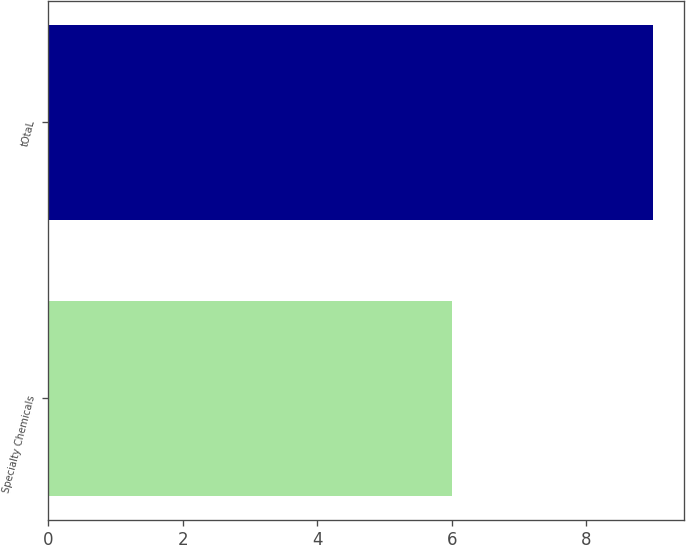<chart> <loc_0><loc_0><loc_500><loc_500><bar_chart><fcel>Specialty Chemicals<fcel>tOtaL<nl><fcel>6<fcel>9<nl></chart> 